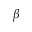Convert formula to latex. <formula><loc_0><loc_0><loc_500><loc_500>\beta</formula> 